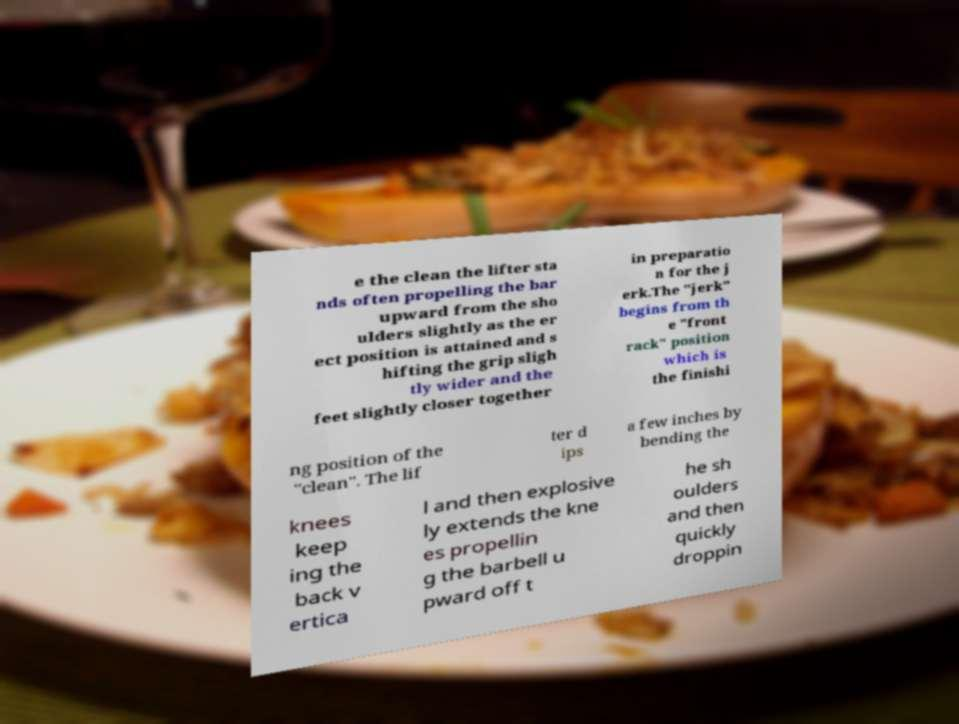Can you accurately transcribe the text from the provided image for me? e the clean the lifter sta nds often propelling the bar upward from the sho ulders slightly as the er ect position is attained and s hifting the grip sligh tly wider and the feet slightly closer together in preparatio n for the j erk.The "jerk" begins from th e "front rack" position which is the finishi ng position of the "clean". The lif ter d ips a few inches by bending the knees keep ing the back v ertica l and then explosive ly extends the kne es propellin g the barbell u pward off t he sh oulders and then quickly droppin 